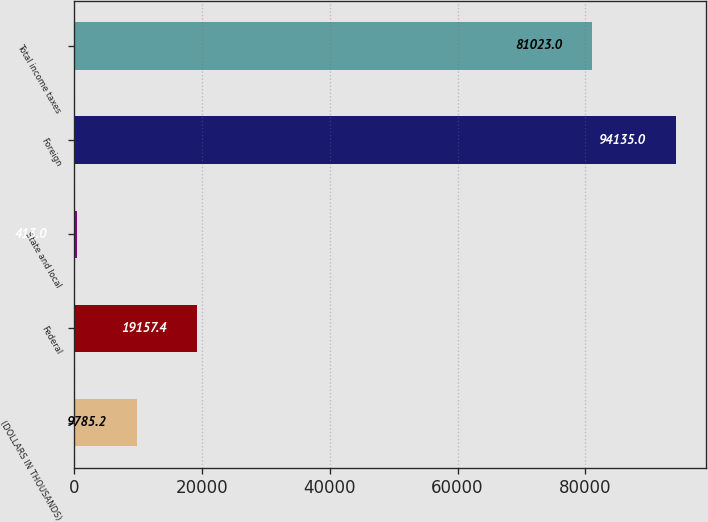Convert chart. <chart><loc_0><loc_0><loc_500><loc_500><bar_chart><fcel>(DOLLARS IN THOUSANDS)<fcel>Federal<fcel>State and local<fcel>Foreign<fcel>Total income taxes<nl><fcel>9785.2<fcel>19157.4<fcel>413<fcel>94135<fcel>81023<nl></chart> 